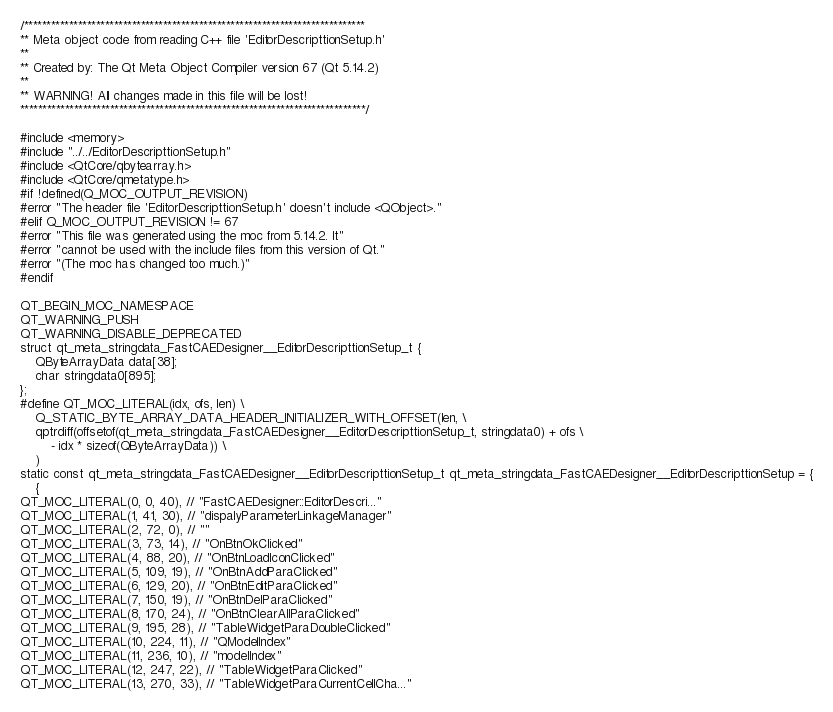Convert code to text. <code><loc_0><loc_0><loc_500><loc_500><_C++_>/****************************************************************************
** Meta object code from reading C++ file 'EditorDescripttionSetup.h'
**
** Created by: The Qt Meta Object Compiler version 67 (Qt 5.14.2)
**
** WARNING! All changes made in this file will be lost!
*****************************************************************************/

#include <memory>
#include "../../EditorDescripttionSetup.h"
#include <QtCore/qbytearray.h>
#include <QtCore/qmetatype.h>
#if !defined(Q_MOC_OUTPUT_REVISION)
#error "The header file 'EditorDescripttionSetup.h' doesn't include <QObject>."
#elif Q_MOC_OUTPUT_REVISION != 67
#error "This file was generated using the moc from 5.14.2. It"
#error "cannot be used with the include files from this version of Qt."
#error "(The moc has changed too much.)"
#endif

QT_BEGIN_MOC_NAMESPACE
QT_WARNING_PUSH
QT_WARNING_DISABLE_DEPRECATED
struct qt_meta_stringdata_FastCAEDesigner__EditorDescripttionSetup_t {
    QByteArrayData data[38];
    char stringdata0[895];
};
#define QT_MOC_LITERAL(idx, ofs, len) \
    Q_STATIC_BYTE_ARRAY_DATA_HEADER_INITIALIZER_WITH_OFFSET(len, \
    qptrdiff(offsetof(qt_meta_stringdata_FastCAEDesigner__EditorDescripttionSetup_t, stringdata0) + ofs \
        - idx * sizeof(QByteArrayData)) \
    )
static const qt_meta_stringdata_FastCAEDesigner__EditorDescripttionSetup_t qt_meta_stringdata_FastCAEDesigner__EditorDescripttionSetup = {
    {
QT_MOC_LITERAL(0, 0, 40), // "FastCAEDesigner::EditorDescri..."
QT_MOC_LITERAL(1, 41, 30), // "dispalyParameterLinkageManager"
QT_MOC_LITERAL(2, 72, 0), // ""
QT_MOC_LITERAL(3, 73, 14), // "OnBtnOkClicked"
QT_MOC_LITERAL(4, 88, 20), // "OnBtnLoadIconClicked"
QT_MOC_LITERAL(5, 109, 19), // "OnBtnAddParaClicked"
QT_MOC_LITERAL(6, 129, 20), // "OnBtnEditParaClicked"
QT_MOC_LITERAL(7, 150, 19), // "OnBtnDelParaClicked"
QT_MOC_LITERAL(8, 170, 24), // "OnBtnClearAllParaClicked"
QT_MOC_LITERAL(9, 195, 28), // "TableWidgetParaDoubleClicked"
QT_MOC_LITERAL(10, 224, 11), // "QModelIndex"
QT_MOC_LITERAL(11, 236, 10), // "modelIndex"
QT_MOC_LITERAL(12, 247, 22), // "TableWidgetParaClicked"
QT_MOC_LITERAL(13, 270, 33), // "TableWidgetParaCurrentCellCha..."</code> 